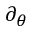<formula> <loc_0><loc_0><loc_500><loc_500>\partial _ { \theta }</formula> 